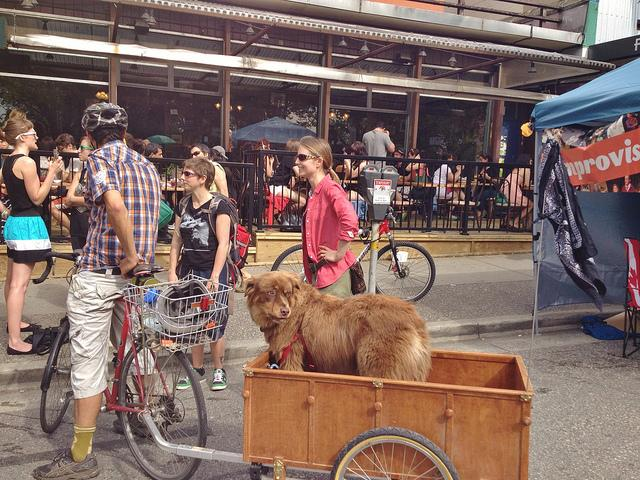What is the dog riding in?

Choices:
A) trolley
B) wagon
C) bus
D) car wagon 